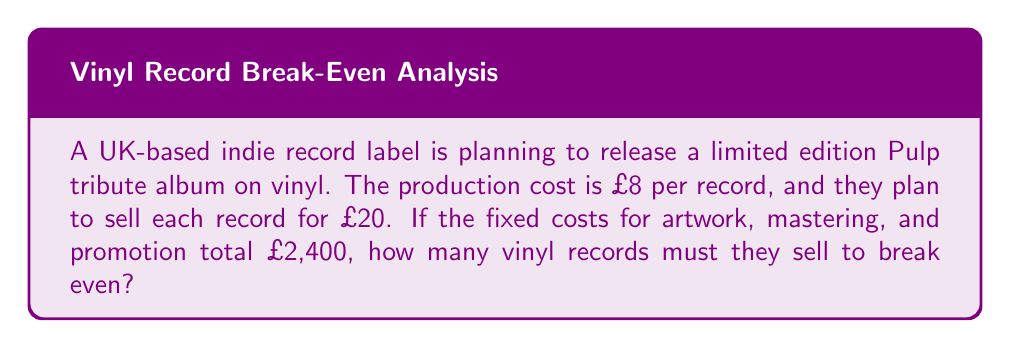Could you help me with this problem? Let's approach this step-by-step:

1) First, we need to define our variables:
   Let $x$ = number of records sold
   
2) The break-even point is where total revenue equals total costs:
   Total Revenue = Total Costs

3) Let's break down each side of the equation:
   Total Revenue = Selling price per record × Number of records sold
   $$ \text{Total Revenue} = 20x $$

   Total Costs = Fixed costs + (Production cost per record × Number of records sold)
   $$ \text{Total Costs} = 2400 + 8x $$

4) Now we can set up our break-even equation:
   $$ 20x = 2400 + 8x $$

5) Solve for $x$:
   $$ 20x - 8x = 2400 $$
   $$ 12x = 2400 $$
   $$ x = 2400 \div 12 = 200 $$

Therefore, the record label needs to sell 200 vinyl records to break even.
Answer: 200 vinyl records 